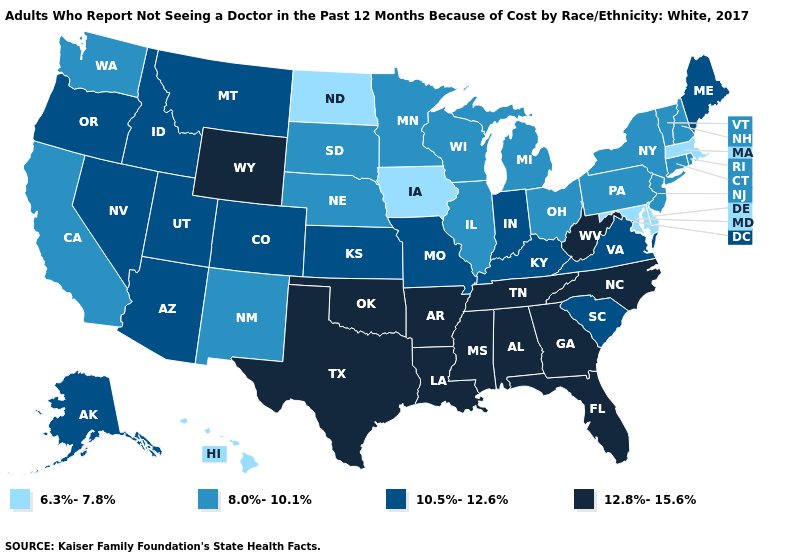Name the states that have a value in the range 12.8%-15.6%?
Answer briefly. Alabama, Arkansas, Florida, Georgia, Louisiana, Mississippi, North Carolina, Oklahoma, Tennessee, Texas, West Virginia, Wyoming. Does Delaware have the lowest value in the USA?
Quick response, please. Yes. What is the value of Hawaii?
Give a very brief answer. 6.3%-7.8%. Name the states that have a value in the range 12.8%-15.6%?
Answer briefly. Alabama, Arkansas, Florida, Georgia, Louisiana, Mississippi, North Carolina, Oklahoma, Tennessee, Texas, West Virginia, Wyoming. Name the states that have a value in the range 8.0%-10.1%?
Short answer required. California, Connecticut, Illinois, Michigan, Minnesota, Nebraska, New Hampshire, New Jersey, New Mexico, New York, Ohio, Pennsylvania, Rhode Island, South Dakota, Vermont, Washington, Wisconsin. Does the map have missing data?
Be succinct. No. Does the map have missing data?
Write a very short answer. No. What is the value of Kentucky?
Be succinct. 10.5%-12.6%. What is the highest value in the USA?
Be succinct. 12.8%-15.6%. Which states have the lowest value in the USA?
Short answer required. Delaware, Hawaii, Iowa, Maryland, Massachusetts, North Dakota. Name the states that have a value in the range 10.5%-12.6%?
Be succinct. Alaska, Arizona, Colorado, Idaho, Indiana, Kansas, Kentucky, Maine, Missouri, Montana, Nevada, Oregon, South Carolina, Utah, Virginia. What is the value of Iowa?
Short answer required. 6.3%-7.8%. What is the value of South Dakota?
Short answer required. 8.0%-10.1%. Which states have the lowest value in the USA?
Be succinct. Delaware, Hawaii, Iowa, Maryland, Massachusetts, North Dakota. Does Wyoming have the highest value in the USA?
Quick response, please. Yes. 